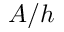<formula> <loc_0><loc_0><loc_500><loc_500>A / h</formula> 